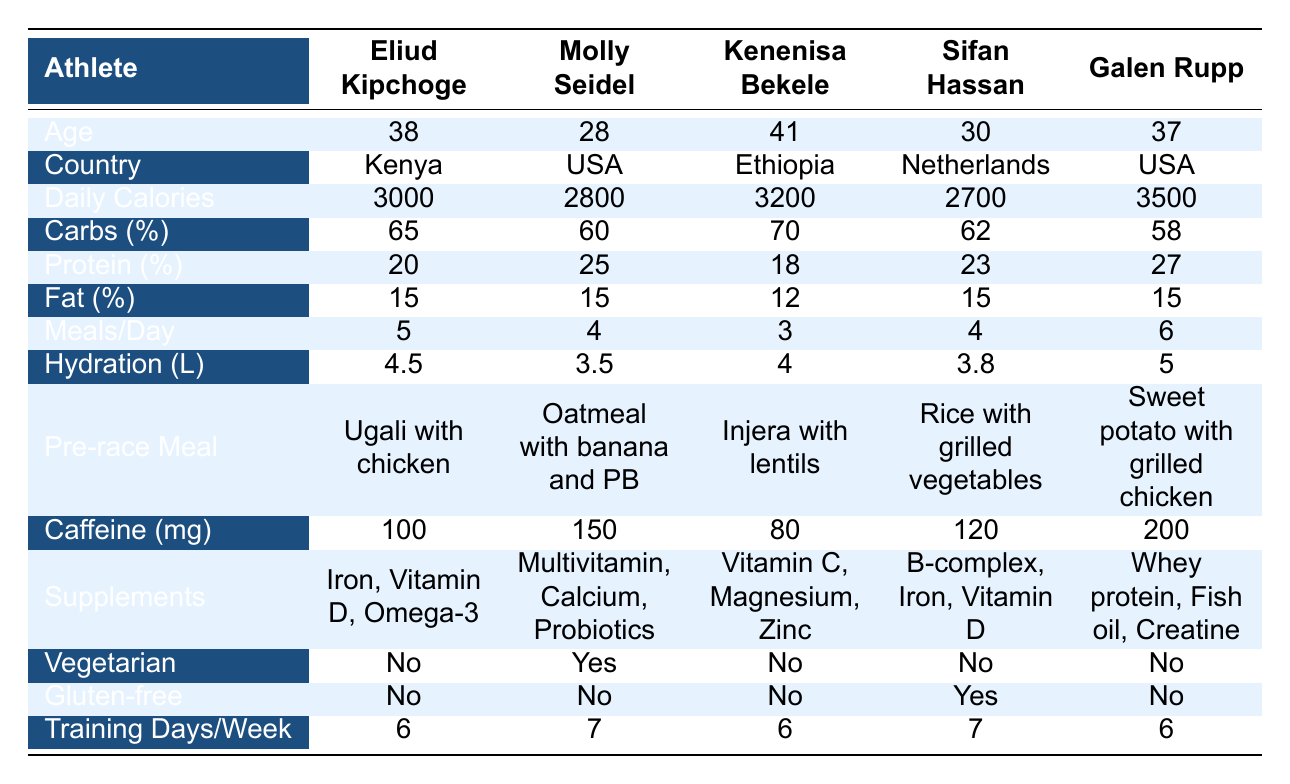What is the highest daily calorie intake among the athletes? Referring to the table, Galen Rupp has the highest daily calorie intake of 3500, as indicated in his row.
Answer: 3500 Who consumes the least amount of caffeine before races? By checking the caffeine consumption values, Kenenisa Bekele consumes the least amount at 80 mg compared to the others.
Answer: 80 mg What is the average number of meals per day consumed by the athletes? To find the average, we sum the meals per day: (5 + 4 + 3 + 4 + 6) = 22, then divide by 5 (the number of athletes): 22 / 5 = 4.4.
Answer: 4.4 Are any of the athletes vegetarian? By looking at the "Vegetarian" column, we see Molly Seidel is the only vegetarian among the athletes listed.
Answer: Yes Which athlete has the highest percentage of carbohydrates in their diet? The athlete with the highest carbohydrate percentage is Kenenisa Bekele at 70%, as seen in his row.
Answer: 70% What is the median age of the athletes? The ages listed are 28, 30, 37, 38, and 41. When arranged in order, the median age (middle value) is 37.
Answer: 37 Do any athletes consume caffeine in excess of 150 mg? Checking the caffeine consumption values shows that both Molly Seidel (150 mg) and Galen Rupp (200 mg) exceed 150 mg.
Answer: Yes What is the total number of liters of hydration consumed daily by all athletes combined? The total hydration in liters is calculated as: (4.5 + 3.5 + 4 + 3.8 + 5) = 21.8 liters.
Answer: 21.8 liters Which athlete trains the most days per week? By examining the "Training Days/Week" column, Molly Seidel and Sifan Hassan both train 7 days per week, which is the highest.
Answer: Molly Seidel and Sifan Hassan Is Kenenisa Bekele's pre-race meal vegetarian? His pre-race meal is Injera with lentils, which is a vegetarian dish, indicating he does consume vegetarian options before races.
Answer: Yes 